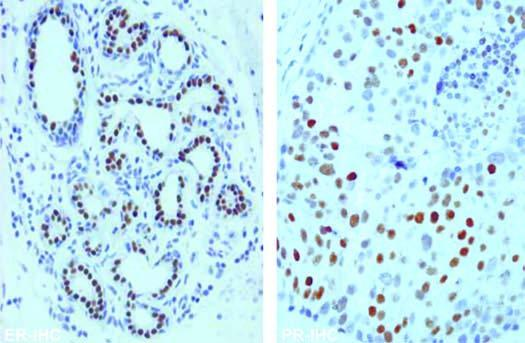what show nuclear positivity with er and pr antibody immunostains?
Answer the question using a single word or phrase. Tumour cells 